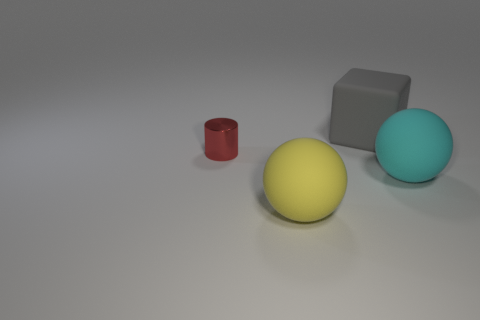What could be the possible use for these objects in a real-world setting? These objects could serve various purposes depending on their material and size. The cylinder could be a container or a part of some mechanical device. The sphere might be used as a decorative element or as part of a child's playset, while the cube could function as a building block, a paperweight, or an educational tool to teach geometry. 